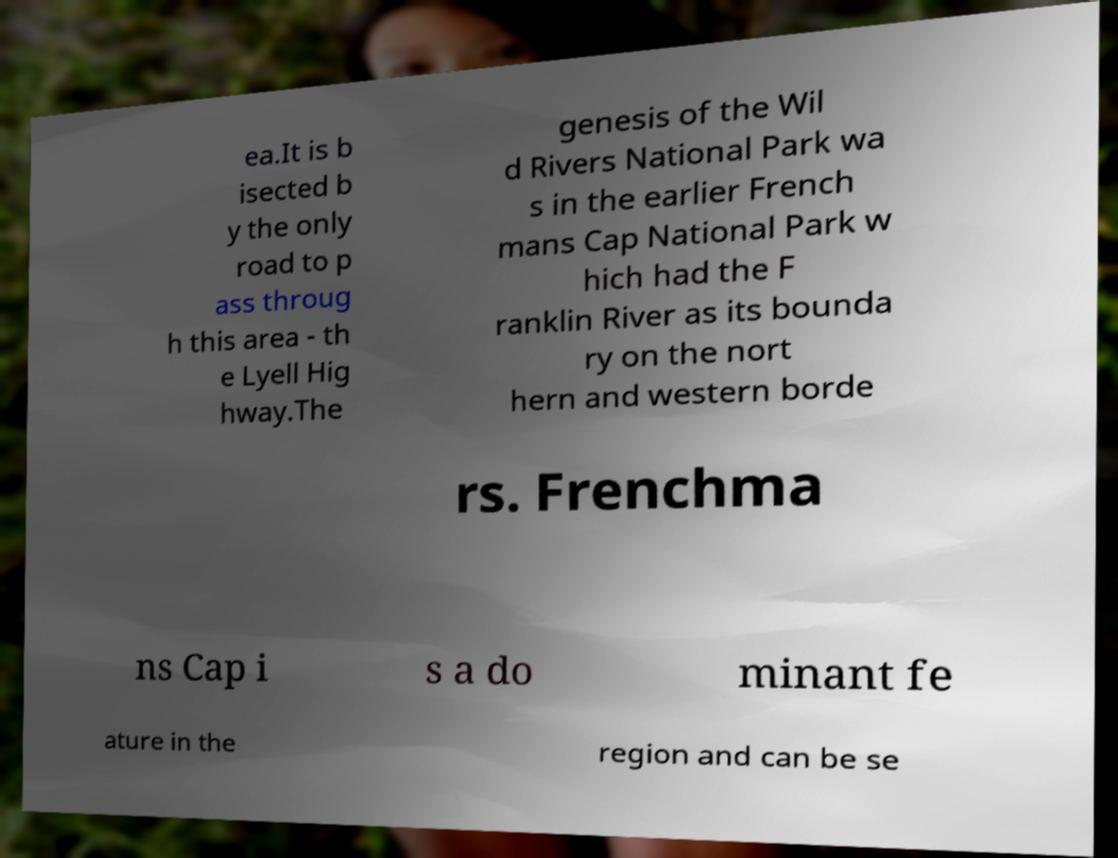Please identify and transcribe the text found in this image. ea.It is b isected b y the only road to p ass throug h this area - th e Lyell Hig hway.The genesis of the Wil d Rivers National Park wa s in the earlier French mans Cap National Park w hich had the F ranklin River as its bounda ry on the nort hern and western borde rs. Frenchma ns Cap i s a do minant fe ature in the region and can be se 